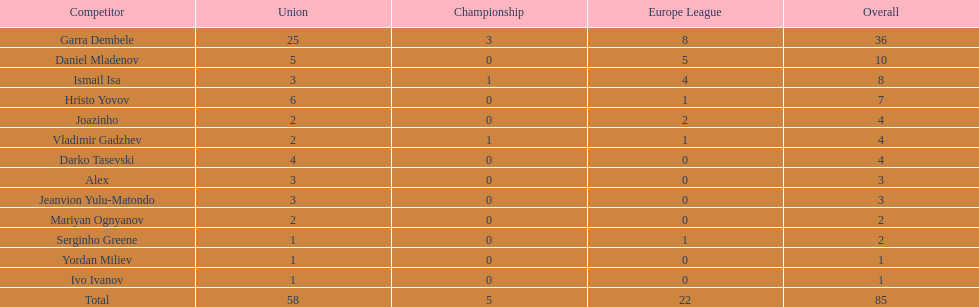How many players had a total of 4? 3. 